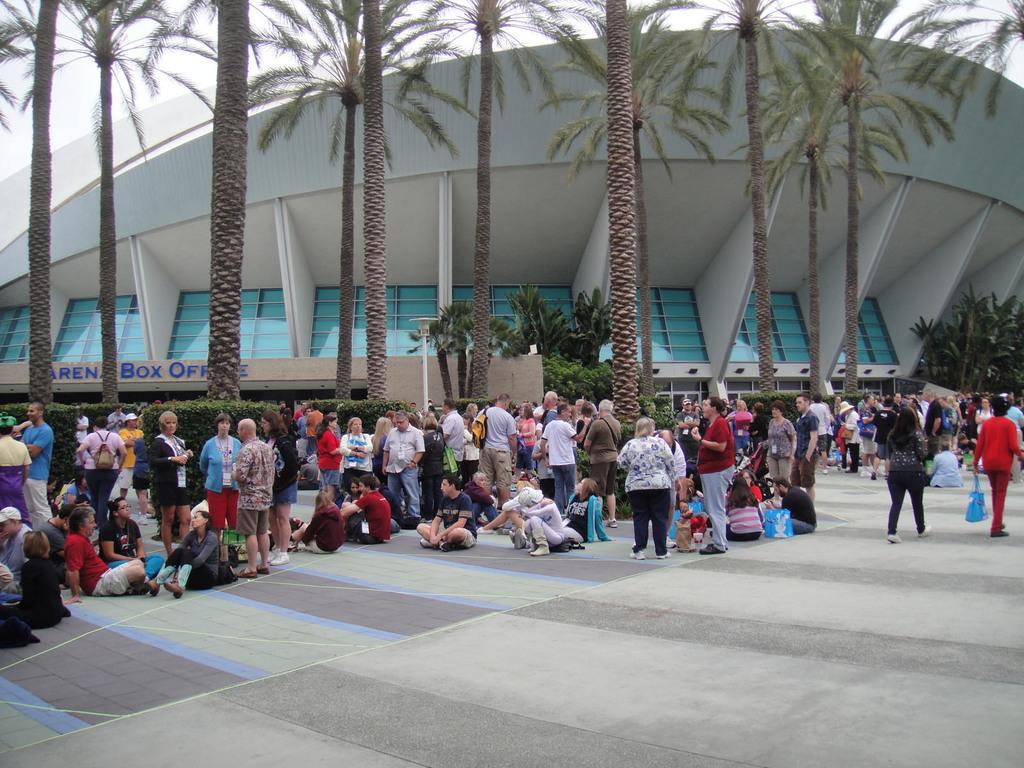In one or two sentences, can you explain what this image depicts? In this picture we can see a group of people where some are sitting on the ground and some are standing, bags, trees, building and in the background we can see the sky. 